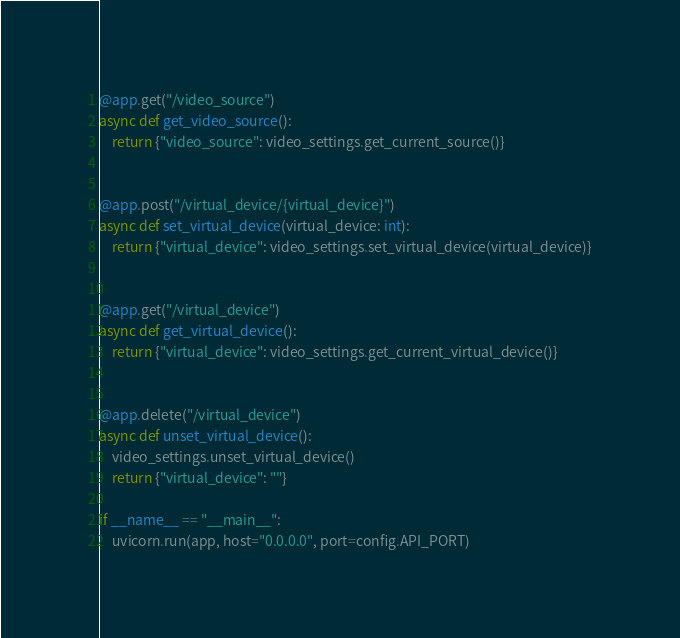<code> <loc_0><loc_0><loc_500><loc_500><_Python_>

@app.get("/video_source")
async def get_video_source():
    return {"video_source": video_settings.get_current_source()}


@app.post("/virtual_device/{virtual_device}")
async def set_virtual_device(virtual_device: int):
    return {"virtual_device": video_settings.set_virtual_device(virtual_device)}


@app.get("/virtual_device")
async def get_virtual_device():
    return {"virtual_device": video_settings.get_current_virtual_device()}


@app.delete("/virtual_device")
async def unset_virtual_device():
    video_settings.unset_virtual_device()
    return {"virtual_device": ""}

if __name__ == "__main__":
    uvicorn.run(app, host="0.0.0.0", port=config.API_PORT)
</code> 